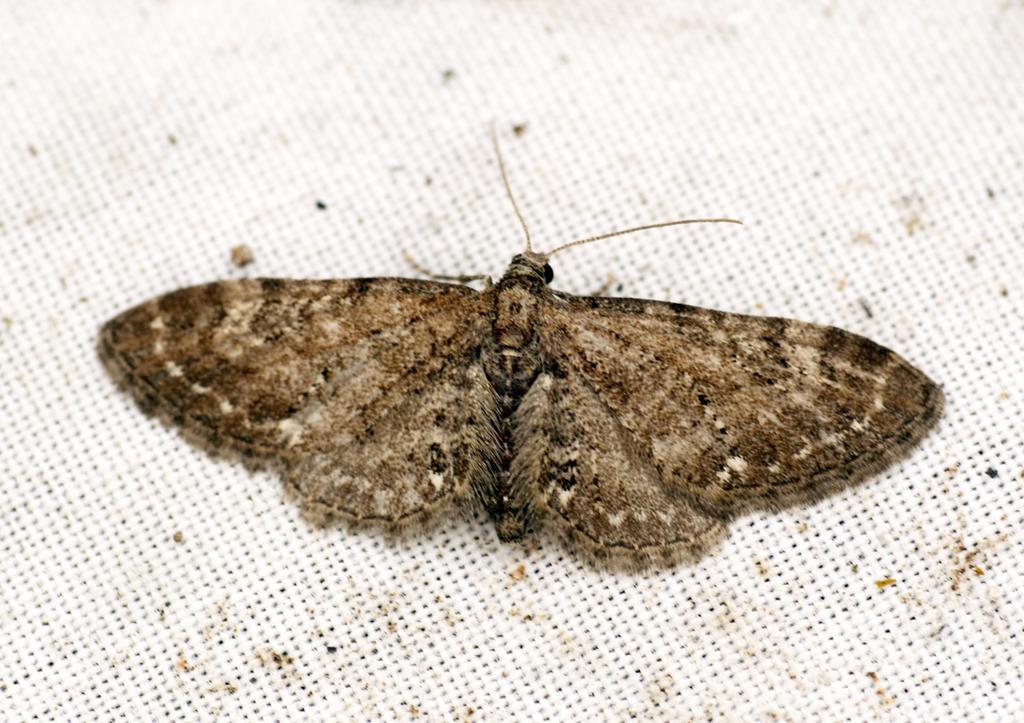Can you describe this image briefly? In this picture I can see a butterfly on an object. 